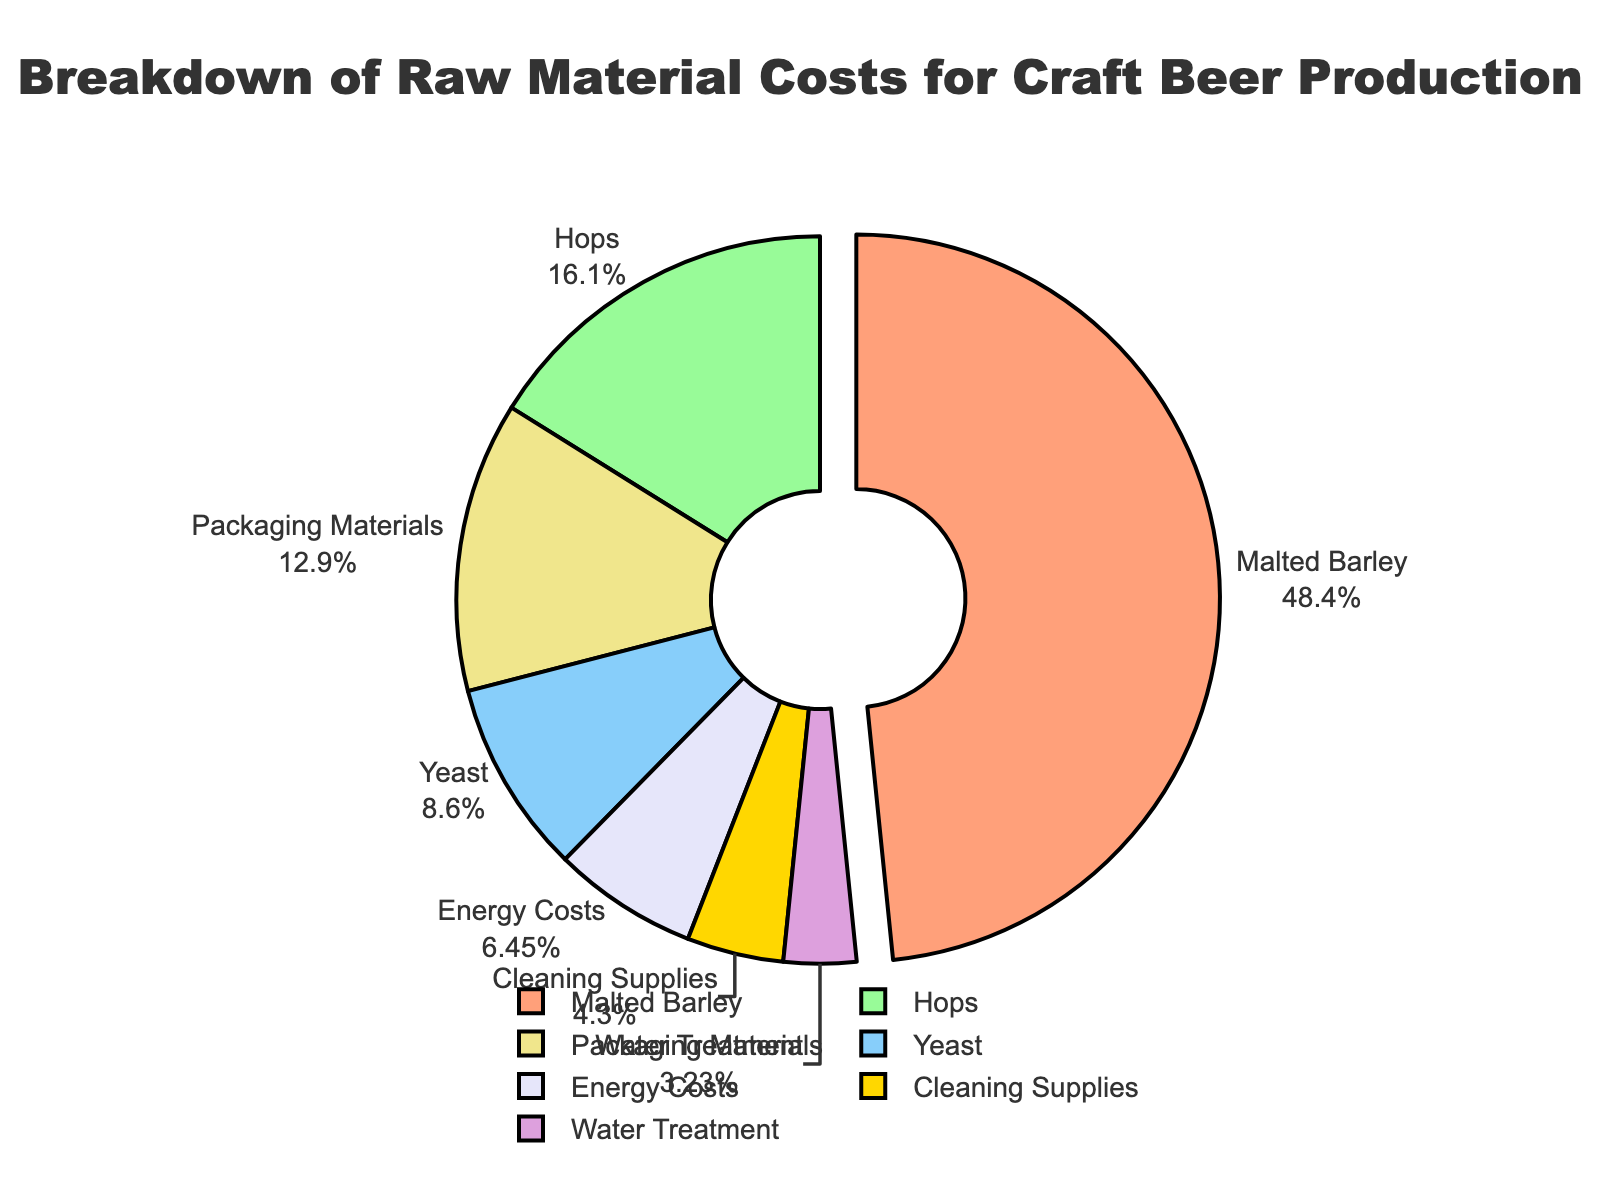Which category has the highest cost percentage? By observing the pie chart, the slice with the highest percentage pulled out slightly and marked is "Malted Barley" with 45%.
Answer: Malted Barley How does the cost for hops compare to the cost for energy? The pie chart shows that hops account for 15% while energy costs account for 6%, so hops cost is higher than energy costs.
Answer: Hops cost more What is the combined cost percentage of wheat, yeast, and water treatment? The chart shows yeast is 8% and water treatment is 3%. Wheat is not listed. Adding the percentages: 8% (yeast) + 3% (water treatment) = 11%.
Answer: 11% Which category is represented by a blue slice, and what is its percentage? By examining the color associated with each slice in the legend, the blue slice represents "Yeast" with a cost percentage of 8%.
Answer: Yeast, 8% What is the difference in cost percentage between packaging materials and cleaning supplies? The pie chart shows Packaging Materials at 12%, and Cleaning Supplies at 4%. Subtracting: 12% (Packaging Materials) - 4% (Cleaning Supplies) = 8%.
Answer: 8% Is the portion for water treatment larger or smaller than the portion for cleaning supplies? The pie chart shows Water Treatment at 3% and Cleaning Supplies at 4%. 3% is smaller than 4%.
Answer: Smaller Which two categories together nearly equal the cost percentage of malted barley? Hops (15%) and Packaging Materials (12%) together sum up: 15% + 12% = 27%. However, Yeast (8%) and Packaging Materials (12%) together sum up: 8% + 12% = 20%, which is closer to Malted Barley at 45%.
Answer: None combination exactly equal to 45%, 8%+ 12%=20% is closed What proportion of the total cost comes from packaging materials and energy costs together? The chart shows packaging materials at 12% and energy costs at 6%. Adding these: 12% + 6% = 18%.
Answer: 18% Comparing the proportions, which has the least cost percentage? From the pie chart, Water Treatment has the smallest percentage of 3%.
Answer: Water Treatment 